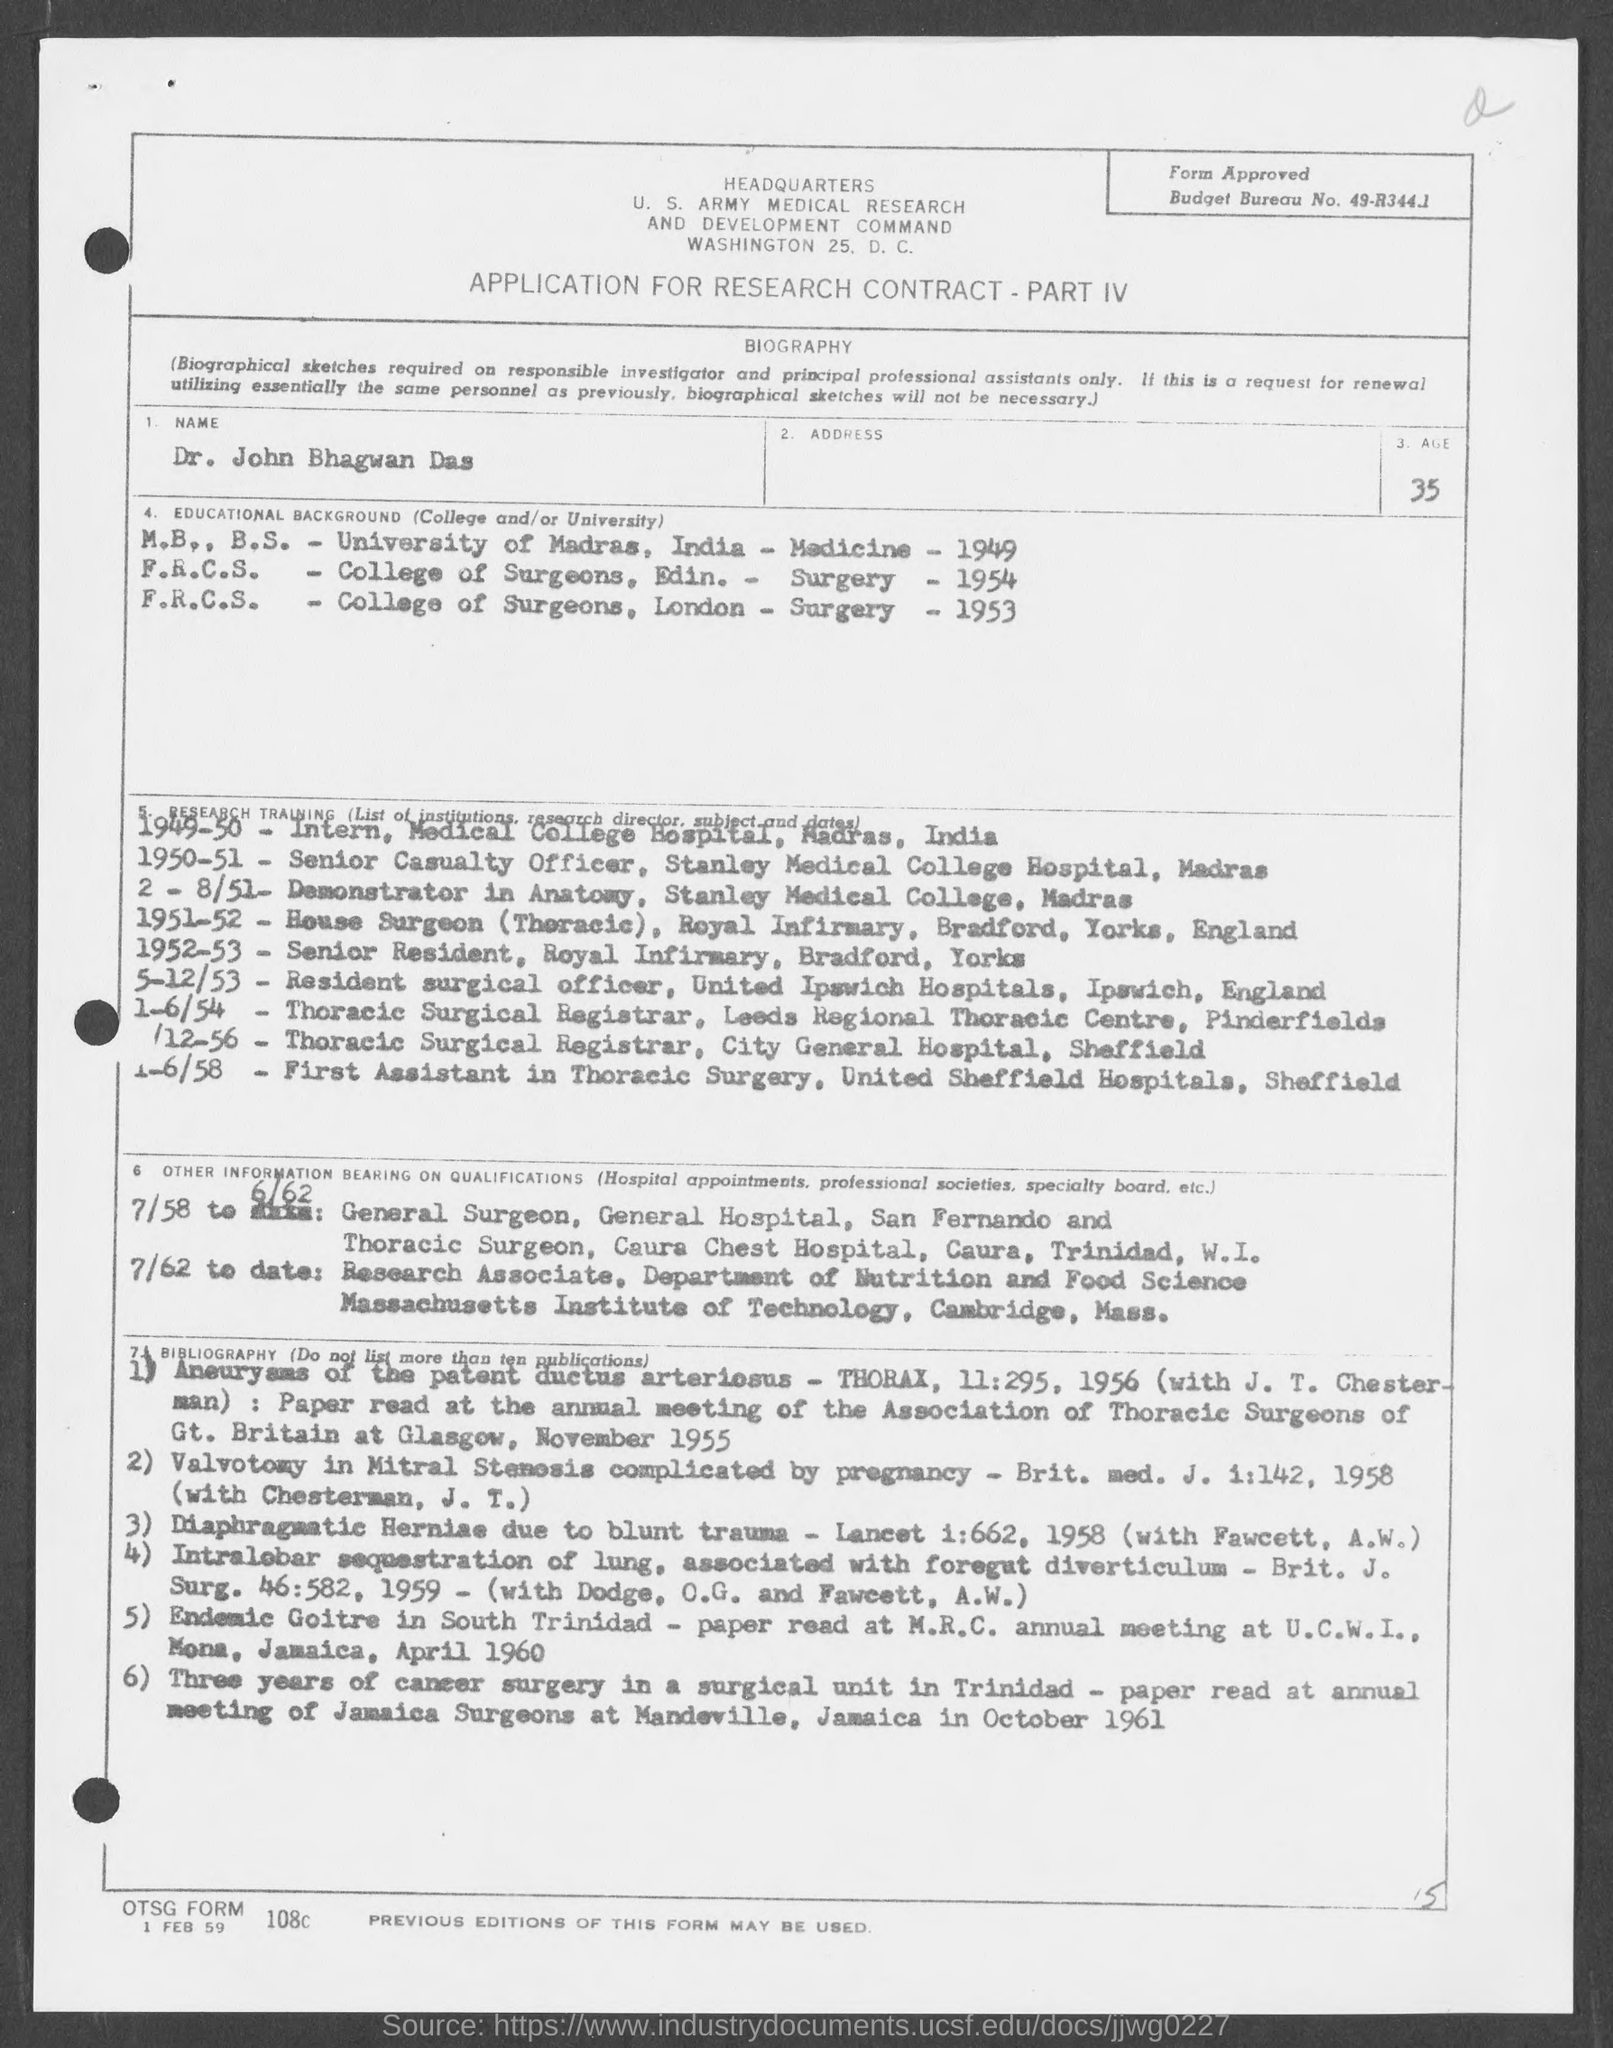What is the Name?
Offer a very short reply. John bhagwan das. What is the Age?
Ensure brevity in your answer.  35. What is the Budget Bureau No.?
Provide a succinct answer. 49-R344.1. What is the date on the document?
Give a very brief answer. 1 Feb 59. 